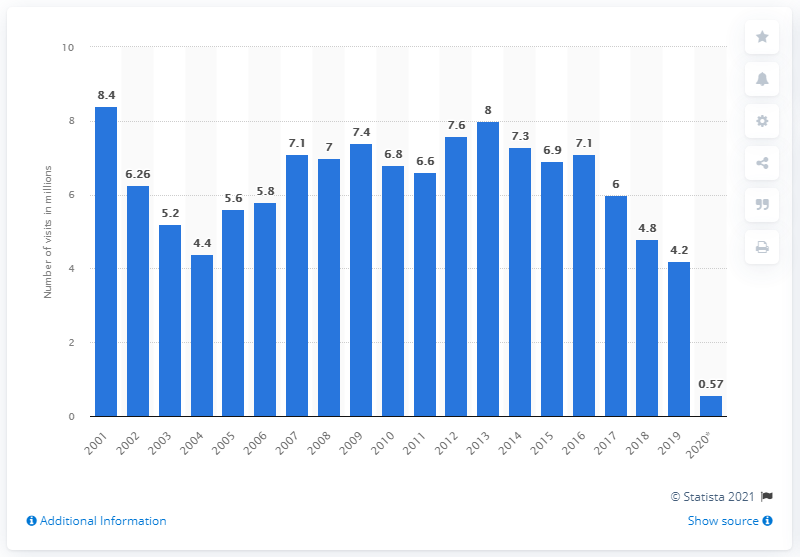Identify some key points in this picture. In 2020, the Smithsonian National Museum of Natural History received approximately 0.57 million visits. 